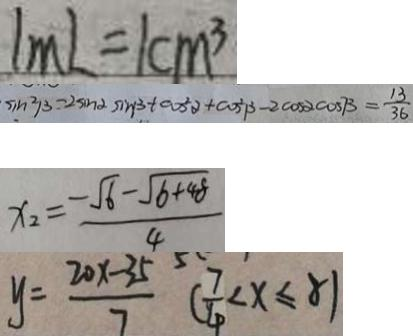<formula> <loc_0><loc_0><loc_500><loc_500>1 m L = 1 c m ^ { 3 } 
 \sin ^ { 2 } \beta - 2 \sin \alpha \sin \beta + \cos ^ { 2 } \alpha + \cos ^ { 2 } \beta - 2 \cos \alpha \cos \beta = \frac { 1 3 } { 3 6 } 
 x _ { 2 } = \frac { - \sqrt { 6 } - \sqrt { 6 + 4 8 } } { 4 } 
 y = \frac { 2 0 x - 3 5 } { 7 } ( \frac { 7 } { 4 } < x \leq 8 )</formula> 